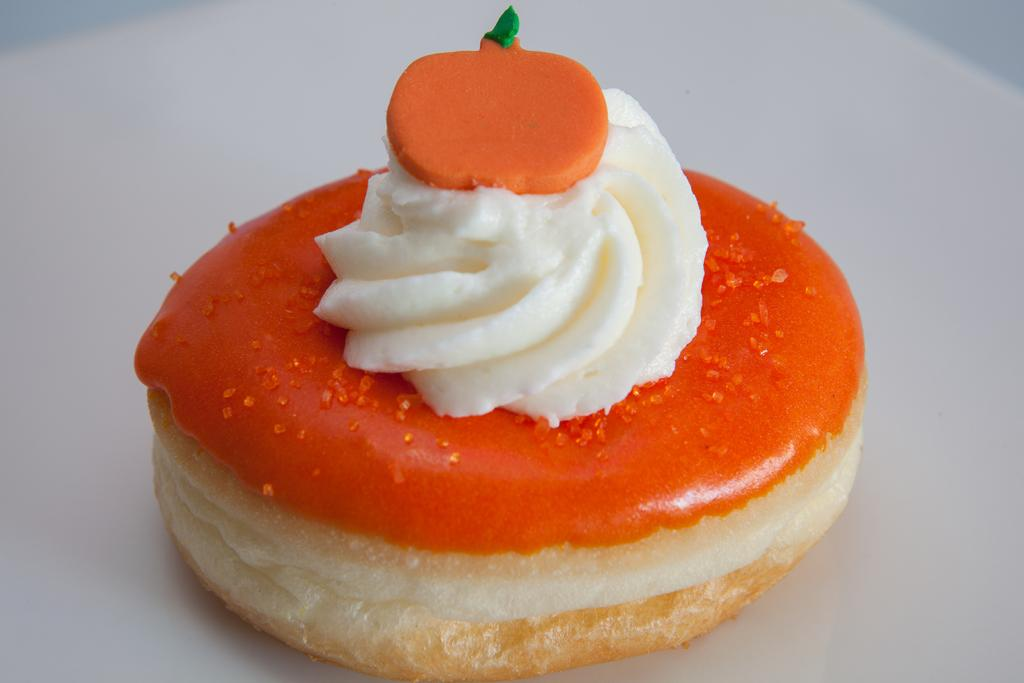What is the main subject of the image? The main subject of the image is food. What is the color of the surface on which the food is placed? The food is on a white surface. What colors can be seen in the food? The food has colors including cream, brown, orange, and green. What type of boat is visible in the image? There is no boat present in the image; it features food on a white surface. What account number is associated with the food in the image? There is no account number associated with the food in the image. 